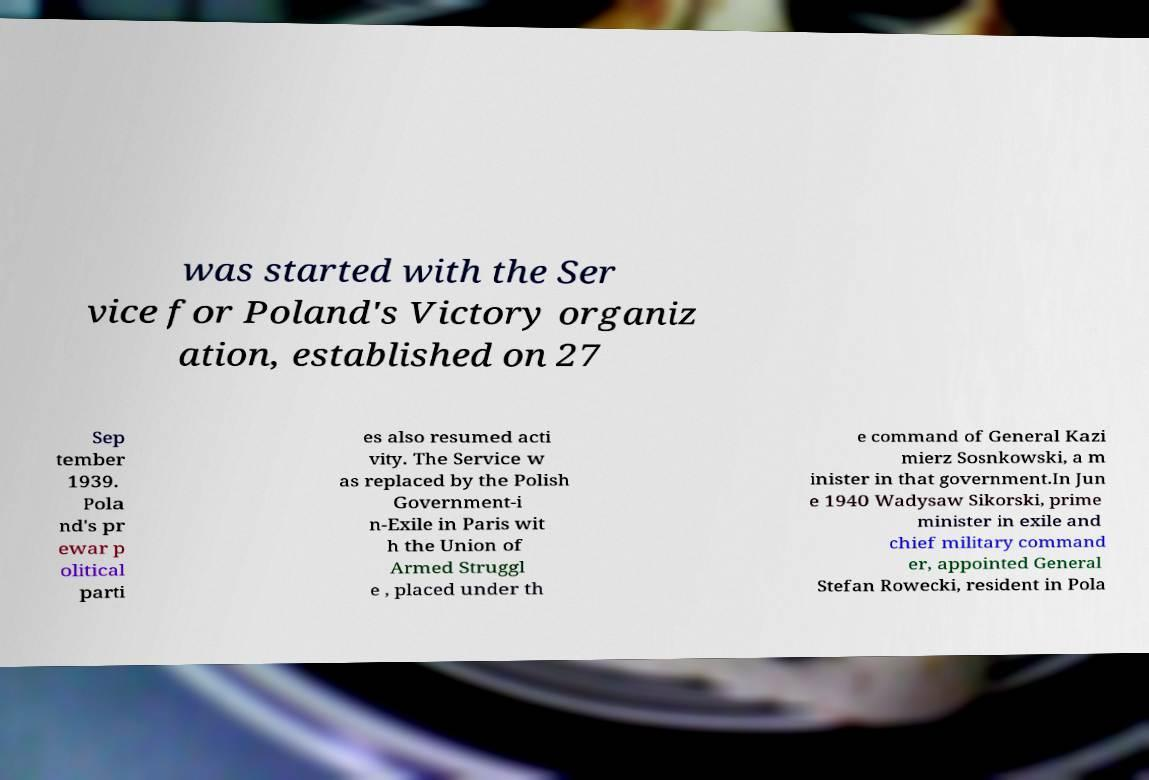What messages or text are displayed in this image? I need them in a readable, typed format. was started with the Ser vice for Poland's Victory organiz ation, established on 27 Sep tember 1939. Pola nd's pr ewar p olitical parti es also resumed acti vity. The Service w as replaced by the Polish Government-i n-Exile in Paris wit h the Union of Armed Struggl e , placed under th e command of General Kazi mierz Sosnkowski, a m inister in that government.In Jun e 1940 Wadysaw Sikorski, prime minister in exile and chief military command er, appointed General Stefan Rowecki, resident in Pola 